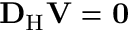Convert formula to latex. <formula><loc_0><loc_0><loc_500><loc_500>{ D } _ { H } V = 0</formula> 